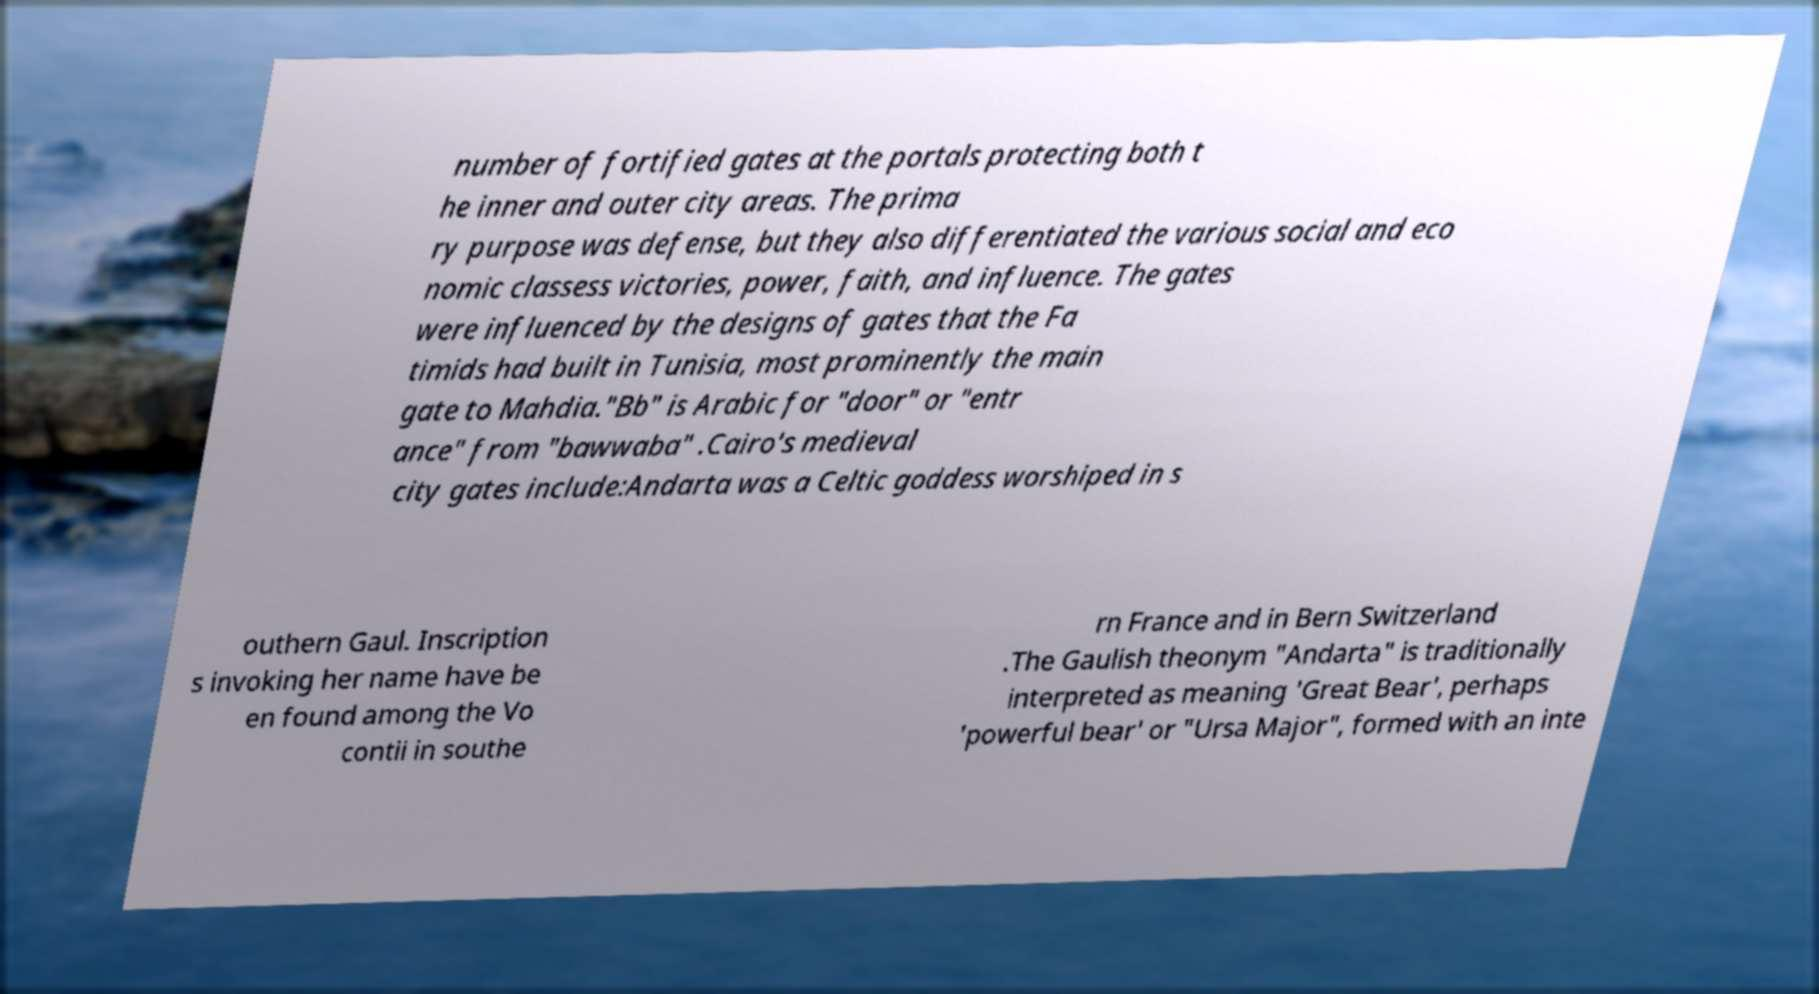Can you read and provide the text displayed in the image?This photo seems to have some interesting text. Can you extract and type it out for me? number of fortified gates at the portals protecting both t he inner and outer city areas. The prima ry purpose was defense, but they also differentiated the various social and eco nomic classess victories, power, faith, and influence. The gates were influenced by the designs of gates that the Fa timids had built in Tunisia, most prominently the main gate to Mahdia."Bb" is Arabic for "door" or "entr ance" from "bawwaba" .Cairo's medieval city gates include:Andarta was a Celtic goddess worshiped in s outhern Gaul. Inscription s invoking her name have be en found among the Vo contii in southe rn France and in Bern Switzerland .The Gaulish theonym "Andarta" is traditionally interpreted as meaning 'Great Bear', perhaps 'powerful bear' or "Ursa Major", formed with an inte 